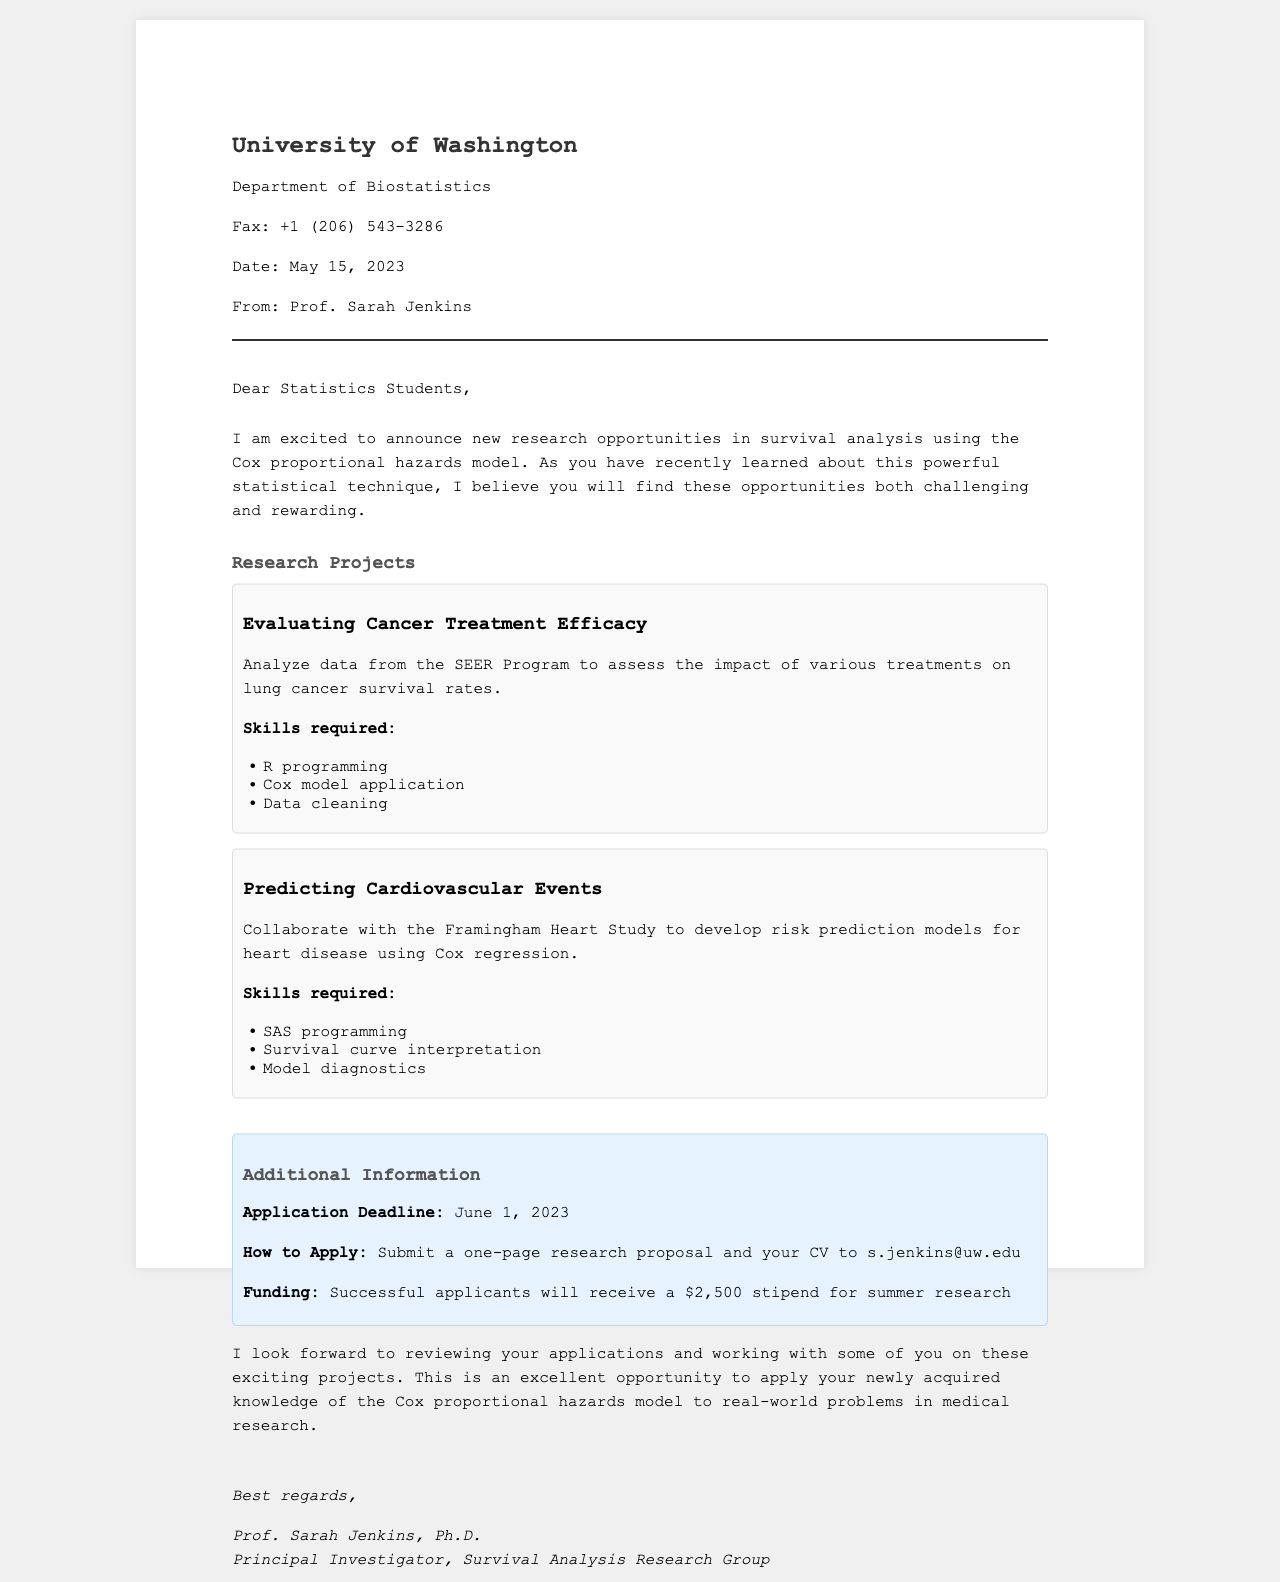What is the name of the sender? The sender of the fax is Prof. Sarah Jenkins, as stated in the document.
Answer: Prof. Sarah Jenkins What is the application deadline? The document specifies that the application deadline is June 1, 2023.
Answer: June 1, 2023 What is the stipend amount for successful applicants? The fax mentions that successful applicants will receive a $2,500 stipend.
Answer: $2,500 What programming skills are required for the cancer treatment project? The document lists R programming, Cox model application, and data cleaning skills for the project.
Answer: R programming What are the main research topics mentioned in the projects section? The two main research topics mentioned are cancer treatment efficacy and cardiovascular event prediction.
Answer: Cancer treatment efficacy and cardiovascular event prediction What email address should proposals be sent to? The email for submitting research proposals is provided in the document as s.jenkins@uw.edu.
Answer: s.jenkins@uw.edu How many projects are listed in the document? There are two research projects detailed in the document.
Answer: Two What is the title of the document? The title of the document is "Research Opportunities in Survival Analysis."
Answer: Research Opportunities in Survival Analysis 